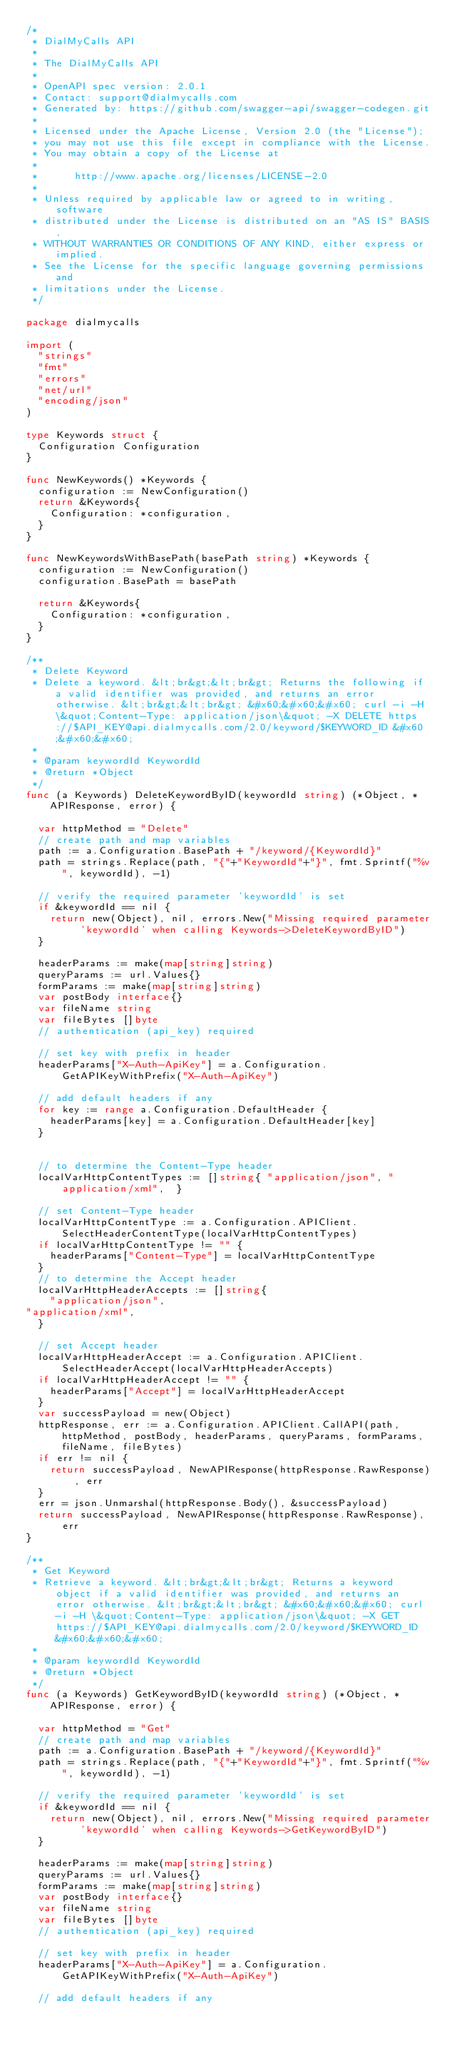Convert code to text. <code><loc_0><loc_0><loc_500><loc_500><_Go_>/* 
 * DialMyCalls API
 *
 * The DialMyCalls API
 *
 * OpenAPI spec version: 2.0.1
 * Contact: support@dialmycalls.com
 * Generated by: https://github.com/swagger-api/swagger-codegen.git
 *
 * Licensed under the Apache License, Version 2.0 (the "License");
 * you may not use this file except in compliance with the License.
 * You may obtain a copy of the License at
 *
 *      http://www.apache.org/licenses/LICENSE-2.0
 *
 * Unless required by applicable law or agreed to in writing, software
 * distributed under the License is distributed on an "AS IS" BASIS,
 * WITHOUT WARRANTIES OR CONDITIONS OF ANY KIND, either express or implied.
 * See the License for the specific language governing permissions and
 * limitations under the License.
 */

package dialmycalls

import (
	"strings"
	"fmt"
	"errors"
	"net/url"
	"encoding/json"
)

type Keywords struct {
	Configuration Configuration
}

func NewKeywords() *Keywords {
	configuration := NewConfiguration()
	return &Keywords{
		Configuration: *configuration,
	}
}

func NewKeywordsWithBasePath(basePath string) *Keywords {
	configuration := NewConfiguration()
	configuration.BasePath = basePath

	return &Keywords{
		Configuration: *configuration,
	}
}

/**
 * Delete Keyword
 * Delete a keyword. &lt;br&gt;&lt;br&gt; Returns the following if a valid identifier was provided, and returns an error otherwise. &lt;br&gt;&lt;br&gt; &#x60;&#x60;&#x60; curl -i -H \&quot;Content-Type: application/json\&quot; -X DELETE https://$API_KEY@api.dialmycalls.com/2.0/keyword/$KEYWORD_ID &#x60;&#x60;&#x60;
 *
 * @param keywordId KeywordId
 * @return *Object
 */
func (a Keywords) DeleteKeywordByID(keywordId string) (*Object, *APIResponse, error) {

	var httpMethod = "Delete"
	// create path and map variables
	path := a.Configuration.BasePath + "/keyword/{KeywordId}"
	path = strings.Replace(path, "{"+"KeywordId"+"}", fmt.Sprintf("%v", keywordId), -1)

	// verify the required parameter 'keywordId' is set
	if &keywordId == nil {
		return new(Object), nil, errors.New("Missing required parameter 'keywordId' when calling Keywords->DeleteKeywordByID")
	}

	headerParams := make(map[string]string)
	queryParams := url.Values{}
	formParams := make(map[string]string)
	var postBody interface{}
	var fileName string
	var fileBytes []byte
	// authentication (api_key) required

	// set key with prefix in header
	headerParams["X-Auth-ApiKey"] = a.Configuration.GetAPIKeyWithPrefix("X-Auth-ApiKey")

	// add default headers if any
	for key := range a.Configuration.DefaultHeader {
		headerParams[key] = a.Configuration.DefaultHeader[key]
	}


	// to determine the Content-Type header
	localVarHttpContentTypes := []string{ "application/json", "application/xml",  }

	// set Content-Type header
	localVarHttpContentType := a.Configuration.APIClient.SelectHeaderContentType(localVarHttpContentTypes)
	if localVarHttpContentType != "" {
		headerParams["Content-Type"] = localVarHttpContentType
	}
	// to determine the Accept header
	localVarHttpHeaderAccepts := []string{
		"application/json",
"application/xml",
	}

	// set Accept header
	localVarHttpHeaderAccept := a.Configuration.APIClient.SelectHeaderAccept(localVarHttpHeaderAccepts)
	if localVarHttpHeaderAccept != "" {
		headerParams["Accept"] = localVarHttpHeaderAccept
	}
	var successPayload = new(Object)
	httpResponse, err := a.Configuration.APIClient.CallAPI(path, httpMethod, postBody, headerParams, queryParams, formParams, fileName, fileBytes)
	if err != nil {
		return successPayload, NewAPIResponse(httpResponse.RawResponse), err
	}
	err = json.Unmarshal(httpResponse.Body(), &successPayload)
	return successPayload, NewAPIResponse(httpResponse.RawResponse), err
}

/**
 * Get Keyword
 * Retrieve a keyword. &lt;br&gt;&lt;br&gt; Returns a keyword object if a valid identifier was provided, and returns an error otherwise. &lt;br&gt;&lt;br&gt; &#x60;&#x60;&#x60; curl -i -H \&quot;Content-Type: application/json\&quot; -X GET https://$API_KEY@api.dialmycalls.com/2.0/keyword/$KEYWORD_ID &#x60;&#x60;&#x60;
 *
 * @param keywordId KeywordId
 * @return *Object
 */
func (a Keywords) GetKeywordByID(keywordId string) (*Object, *APIResponse, error) {

	var httpMethod = "Get"
	// create path and map variables
	path := a.Configuration.BasePath + "/keyword/{KeywordId}"
	path = strings.Replace(path, "{"+"KeywordId"+"}", fmt.Sprintf("%v", keywordId), -1)

	// verify the required parameter 'keywordId' is set
	if &keywordId == nil {
		return new(Object), nil, errors.New("Missing required parameter 'keywordId' when calling Keywords->GetKeywordByID")
	}

	headerParams := make(map[string]string)
	queryParams := url.Values{}
	formParams := make(map[string]string)
	var postBody interface{}
	var fileName string
	var fileBytes []byte
	// authentication (api_key) required

	// set key with prefix in header
	headerParams["X-Auth-ApiKey"] = a.Configuration.GetAPIKeyWithPrefix("X-Auth-ApiKey")

	// add default headers if any</code> 